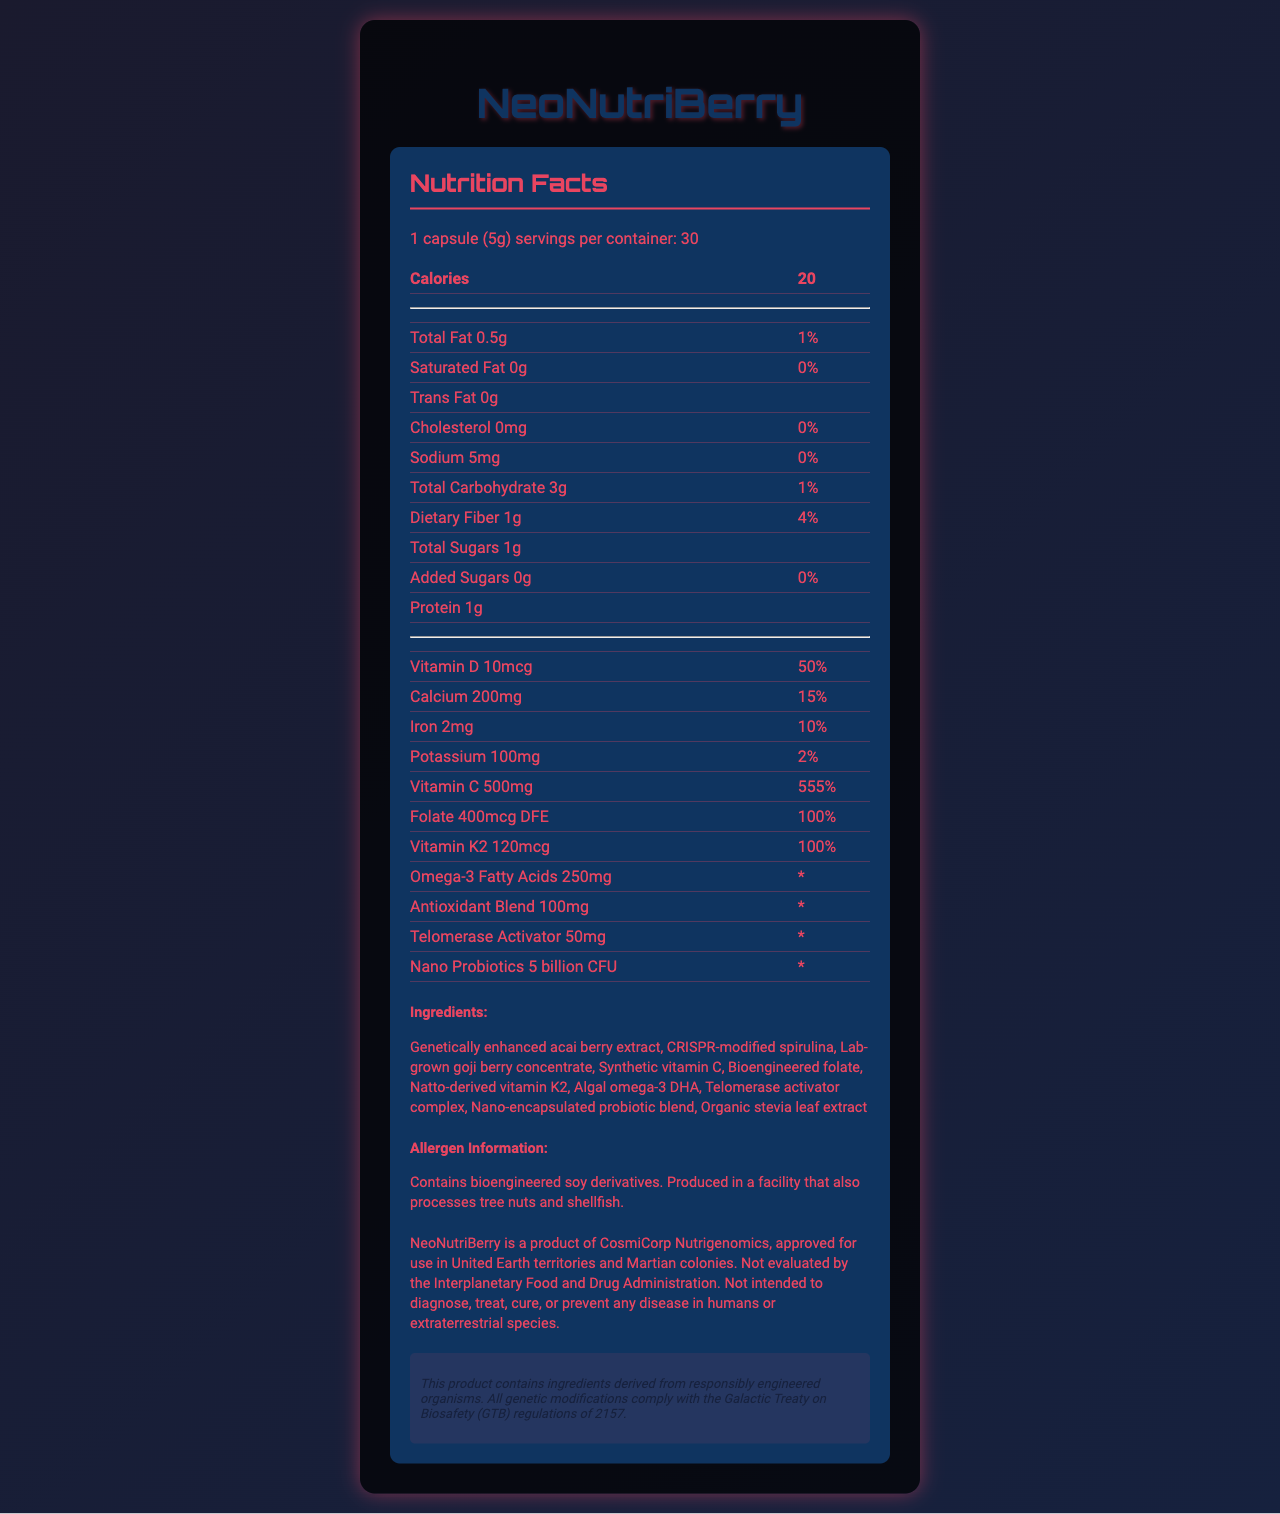who manufactures NeoNutriBerry? The sci-fi disclaimer on the Nutrition Facts Label states that NeoNutriBerry is a product of CosmiCorp Nutrigenomics.
Answer: CosmiCorp Nutrigenomics How many capsules are there in one container of NeoNutriBerry? The serving information specifies that there are 30 servings per container, and the serving size is 1 capsule.
Answer: 30 What is the primary source of Vitamin K2 in NeoNutriBerry? The ingredients list mentions Natto-derived vitamin K2 as one of the components.
Answer: Natto-derived vitamin K2 How much Vitamin C does one capsule contain, and what percentage of the daily value does this represent? The Nutrition Facts specify that 1 capsule contains 500mg of Vitamin C, which is 555% of the daily value.
Answer: 500mg, 555% What is the amount of omega-3 fatty acids in a serving? According to the Nutrition Facts, each serving contains 250mg of omega-3 fatty acids.
Answer: 250mg Which ingredient in NeoNutriBerry is described as being lab-grown? The ingredients list includes lab-grown goji berry concentrate.
Answer: Goji berry concentrate Does NeoNutriBerry contain any dietary fiber? The Nutrition Facts state that there is 1g of dietary fiber per serving.
Answer: Yes What is the daily value percentage of Folate in NeoNutriBerry? A. 50% B. 75% C. 100% D. 150% The Nutrition Facts list the daily value of Folate as 100%.
Answer: C. 100% From which facility characteristic could potential allergen exposure come? A. Tree nuts and shellfish B. Wheat and gluten C. Dairy and eggs The allergen information states that the product is produced in a facility that also processes tree nuts and shellfish.
Answer: A. Tree nuts and shellfish Is NeoNutriBerry evaluated by the Interplanetary Food and Drug Administration? The sci-fi disclaimer mentions that the product is not evaluated by the Interplanetary Food and Drug Administration.
Answer: No Describe the main idea of NeoNutriBerry's Nutrition Facts Label. The label details the nutritional information, ingredients, allergen warnings, and regulatory disclaimers for NeoNutriBerry, emphasizing its futuristic and genetically modified nature.
Answer: NeoNutriBerry is a genetically engineered super-food produced by CosmiCorp Nutrigenomics. The nutrition label outlines serving size, nutritional content, ingredients, and includes disclaimers related to allergies and regulatory approvals. The primary nutritional highlights include high levels of Vitamin C and D, calcium, iron, and various genetically engineered components. How many servings of NeoNutriBerry should one consume to achieve 100% of the daily value for Vitamin D? The Nutrition Facts state that one serving provides 50% of the daily value for Vitamin D, so two servings would be needed to achieve 100%.
Answer: 2 servings Is the genome editing technology used in all ingredients of NeoNutriBerry? The document states some ingredients as genetically enhanced, CRISPR-modified, etc., but it does not specify if every single ingredient uses genome editing technology.
Answer: Cannot be determined 